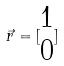<formula> <loc_0><loc_0><loc_500><loc_500>\vec { r } = [ \begin{matrix} 1 \\ 0 \end{matrix} ]</formula> 